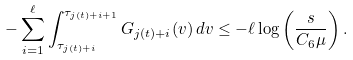<formula> <loc_0><loc_0><loc_500><loc_500>- \sum _ { i = 1 } ^ { \ell } \int _ { \tau _ { j ( t ) + i } } ^ { \tau _ { j ( t ) + i + 1 } } G _ { j ( t ) + i } ( v ) \, d v \leq - \ell \log \left ( \frac { s } { C _ { 6 } \mu } \right ) .</formula> 